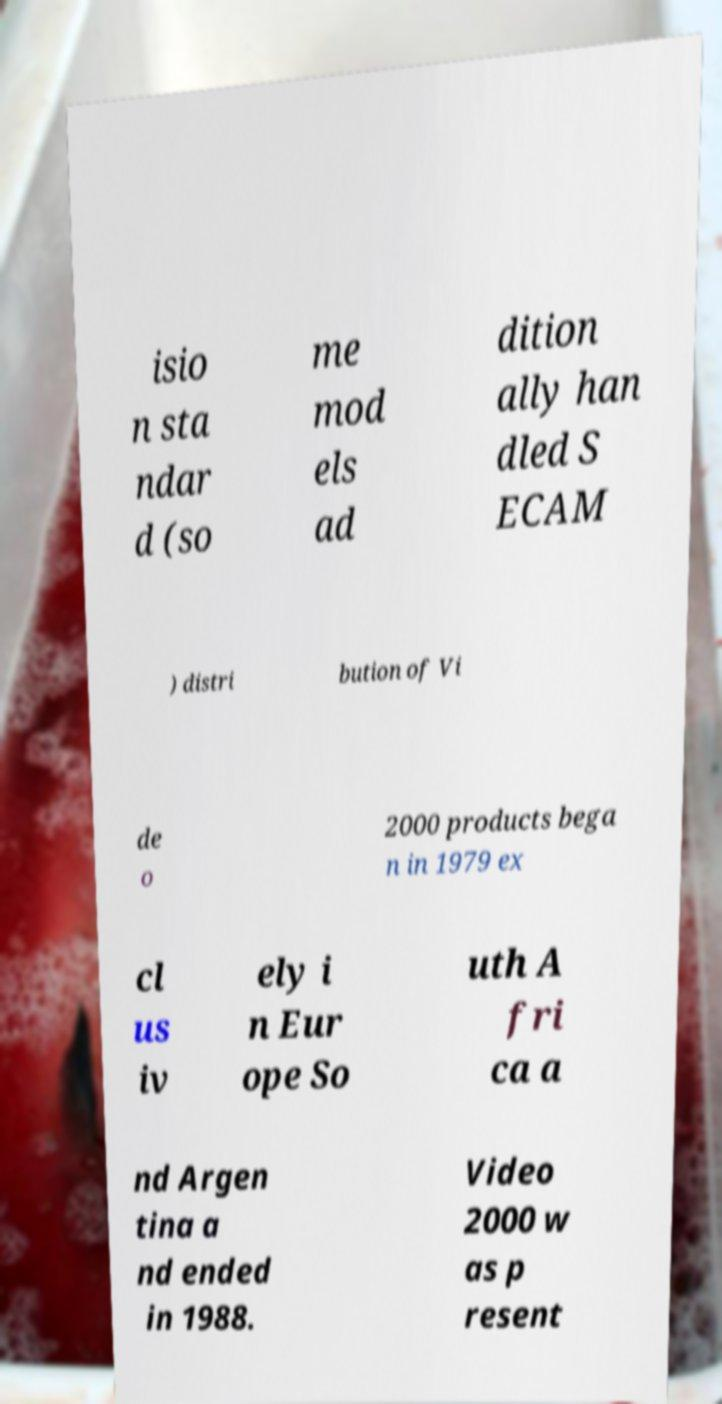Could you extract and type out the text from this image? isio n sta ndar d (so me mod els ad dition ally han dled S ECAM ) distri bution of Vi de o 2000 products bega n in 1979 ex cl us iv ely i n Eur ope So uth A fri ca a nd Argen tina a nd ended in 1988. Video 2000 w as p resent 